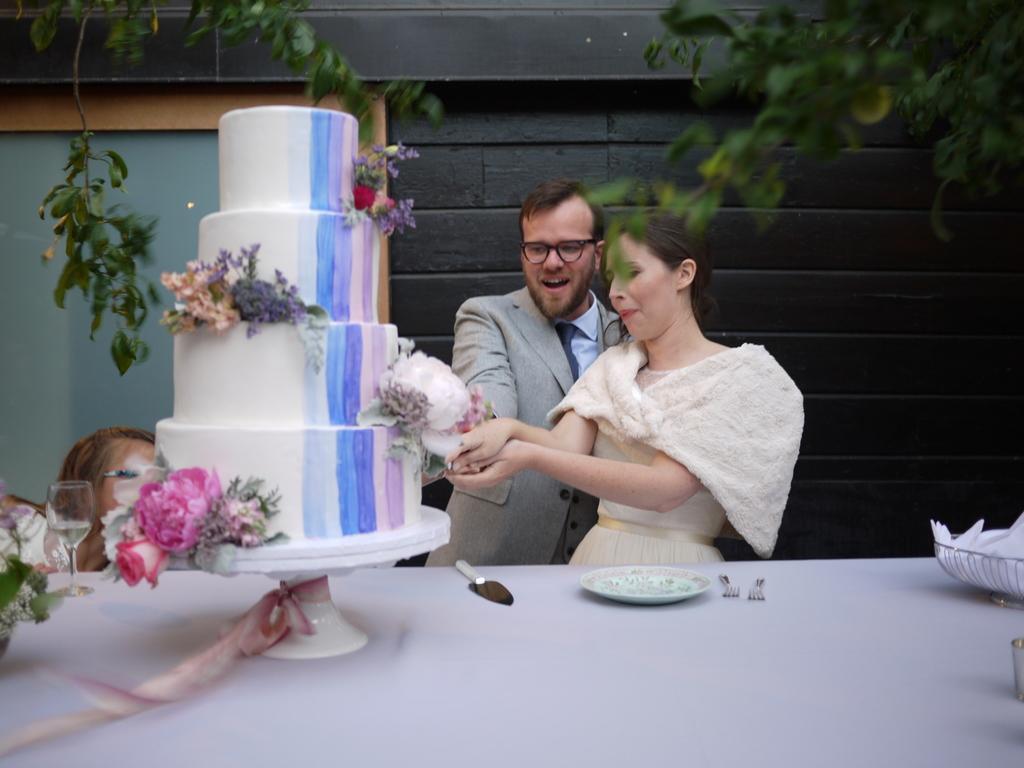Can you describe this image briefly? Here we can see two persons are standing on and holding a cake in their hands, and in front there is the table , knife and plates and some other objects on it, and at back here is the wall. 